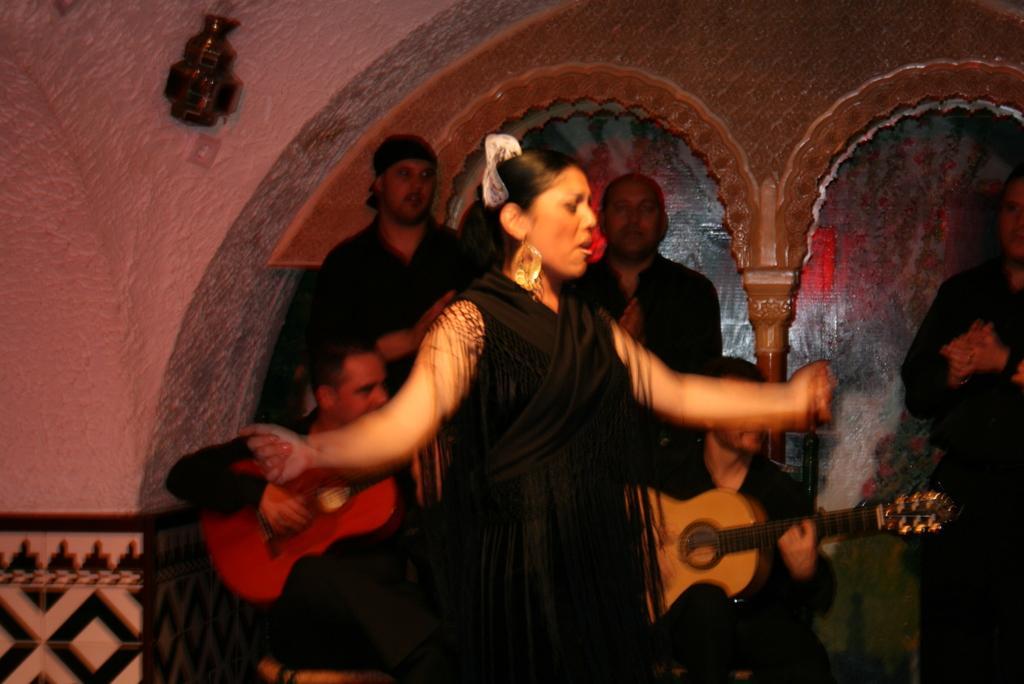Please provide a concise description of this image. In this picture we can find a woman singing and there are few persons standing behind them. One of them is playing guitar. 